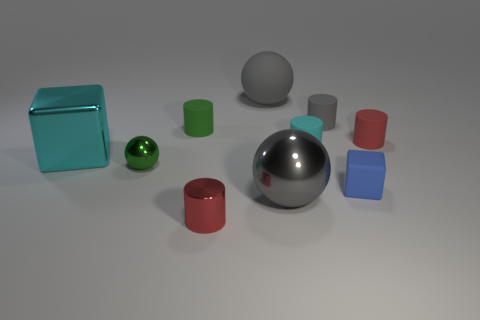There is a small cube; is it the same color as the tiny matte cylinder that is on the right side of the matte cube?
Your response must be concise. No. How big is the cyan object that is right of the small green object in front of the red cylinder that is right of the gray cylinder?
Offer a terse response. Small. What number of objects are the same color as the big matte ball?
Your answer should be very brief. 2. What number of things are either tiny blue rubber blocks or cylinders that are in front of the small sphere?
Keep it short and to the point. 2. The big cube is what color?
Provide a succinct answer. Cyan. There is a cylinder that is in front of the cyan rubber cylinder; what is its color?
Your response must be concise. Red. What number of tiny green cylinders are in front of the rubber object that is in front of the small ball?
Offer a terse response. 0. Do the gray shiny object and the cylinder that is in front of the green metal object have the same size?
Keep it short and to the point. No. Is there a purple object of the same size as the red matte cylinder?
Your answer should be very brief. No. What number of things are red metal things or small gray matte things?
Your answer should be compact. 2. 